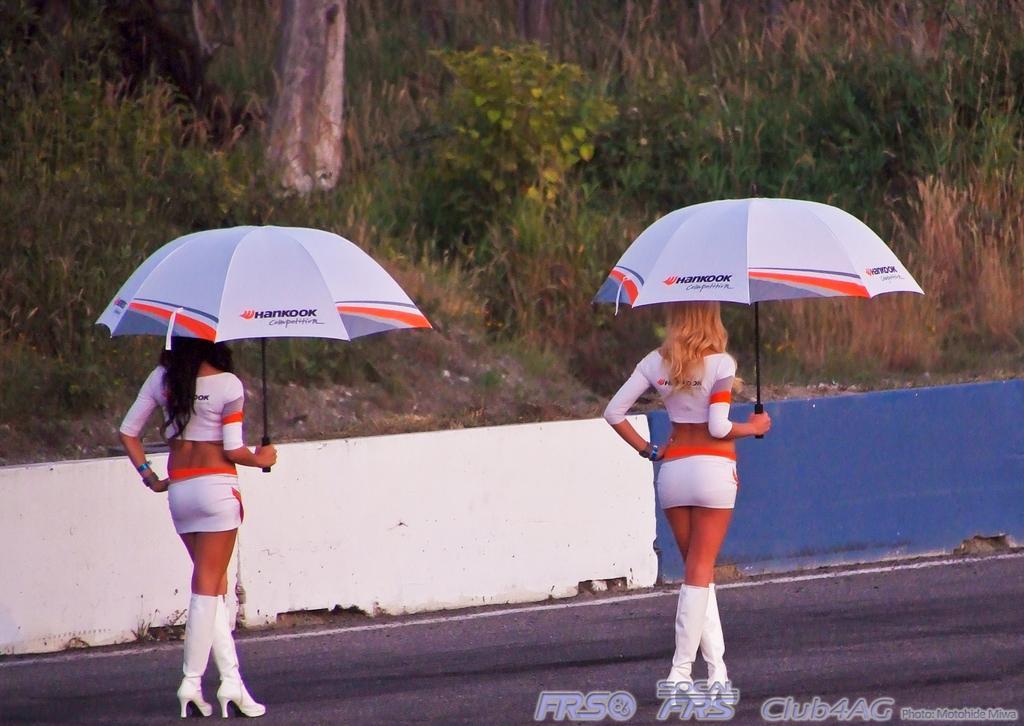Could you give a brief overview of what you see in this image? In the image there are two ladies with white dress is standing on the road and they are holding the white umbrellas in their hands. Behind them there is a small wall with white and blue color. In the background there are trees and plants on the ground. 